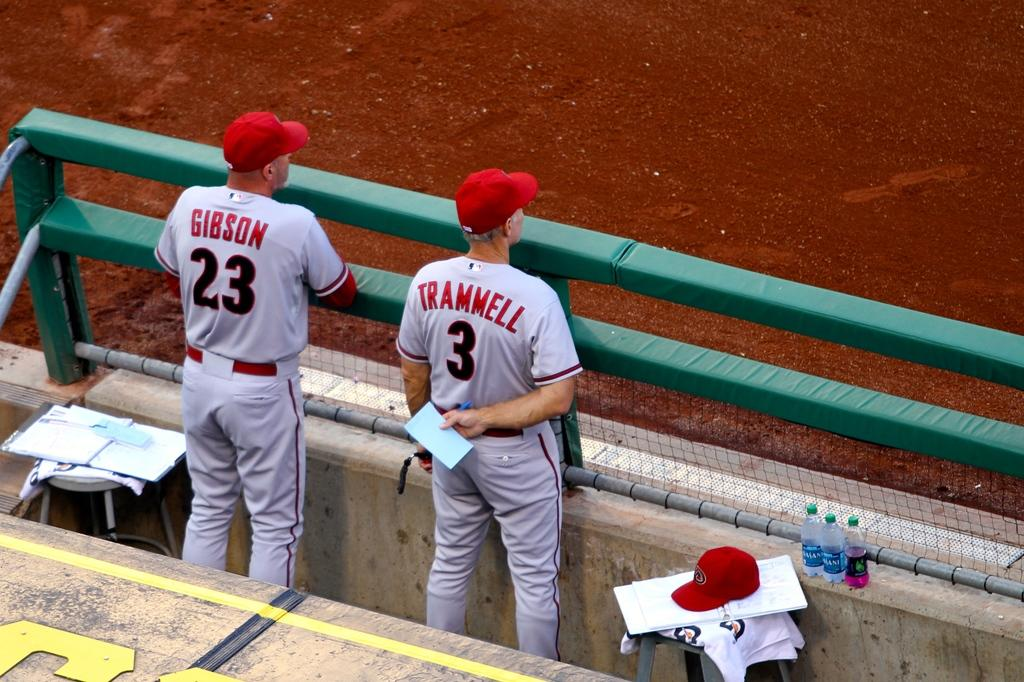<image>
Create a compact narrative representing the image presented. A man, named Trammell, is wearing jersey number 3. 